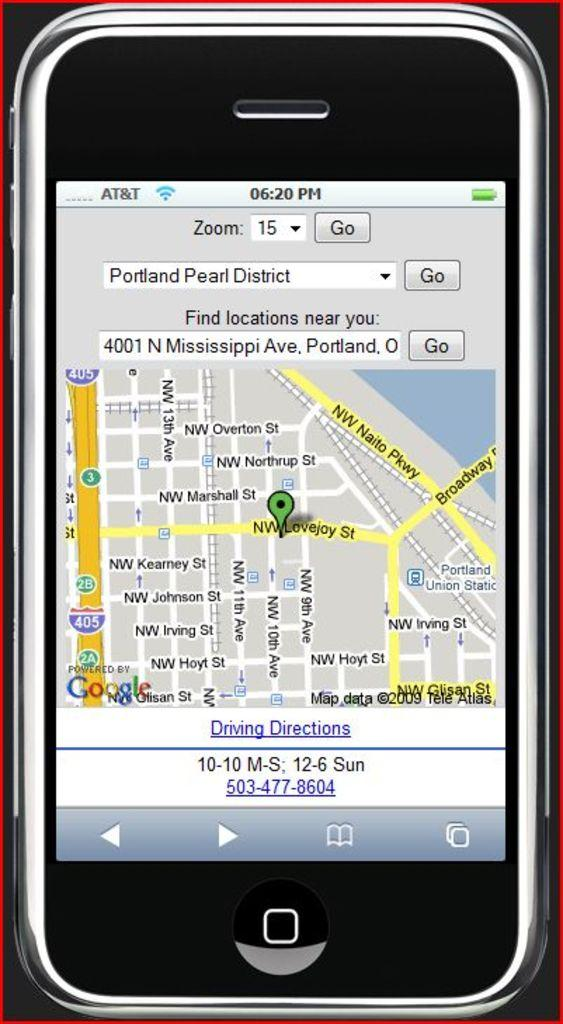<image>
Provide a brief description of the given image. An iphone is displaying a mapped route from Portlands pearl district to Mississippi Ave in Portland. 